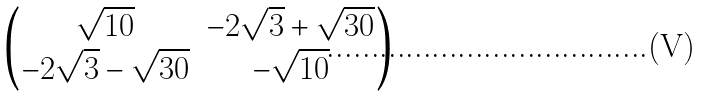<formula> <loc_0><loc_0><loc_500><loc_500>\begin{pmatrix} \sqrt { 1 0 } & - 2 \sqrt { 3 } + \sqrt { 3 0 } \\ - 2 \sqrt { 3 } - \sqrt { 3 0 } & - \sqrt { 1 0 } \end{pmatrix}</formula> 